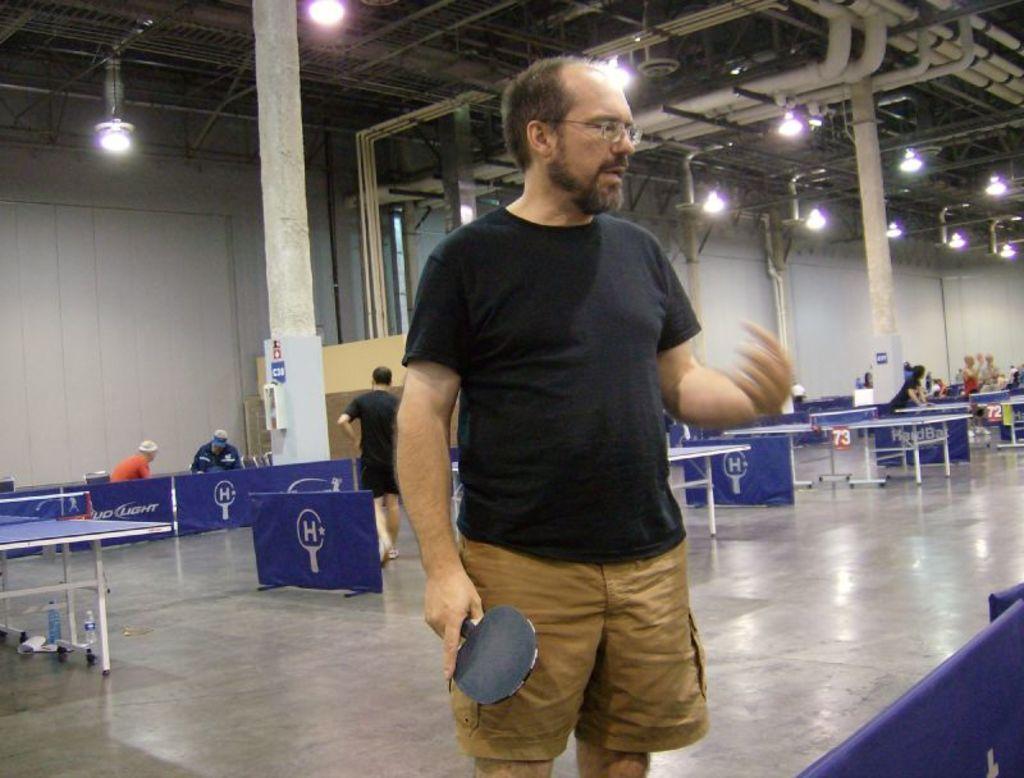Could you give a brief overview of what you see in this image? In this image we can see people standing on the floor and holding bats in their hands. In the background there are electric lights, pipelines, tables, disposal bottles, sign boards and advertisements. 